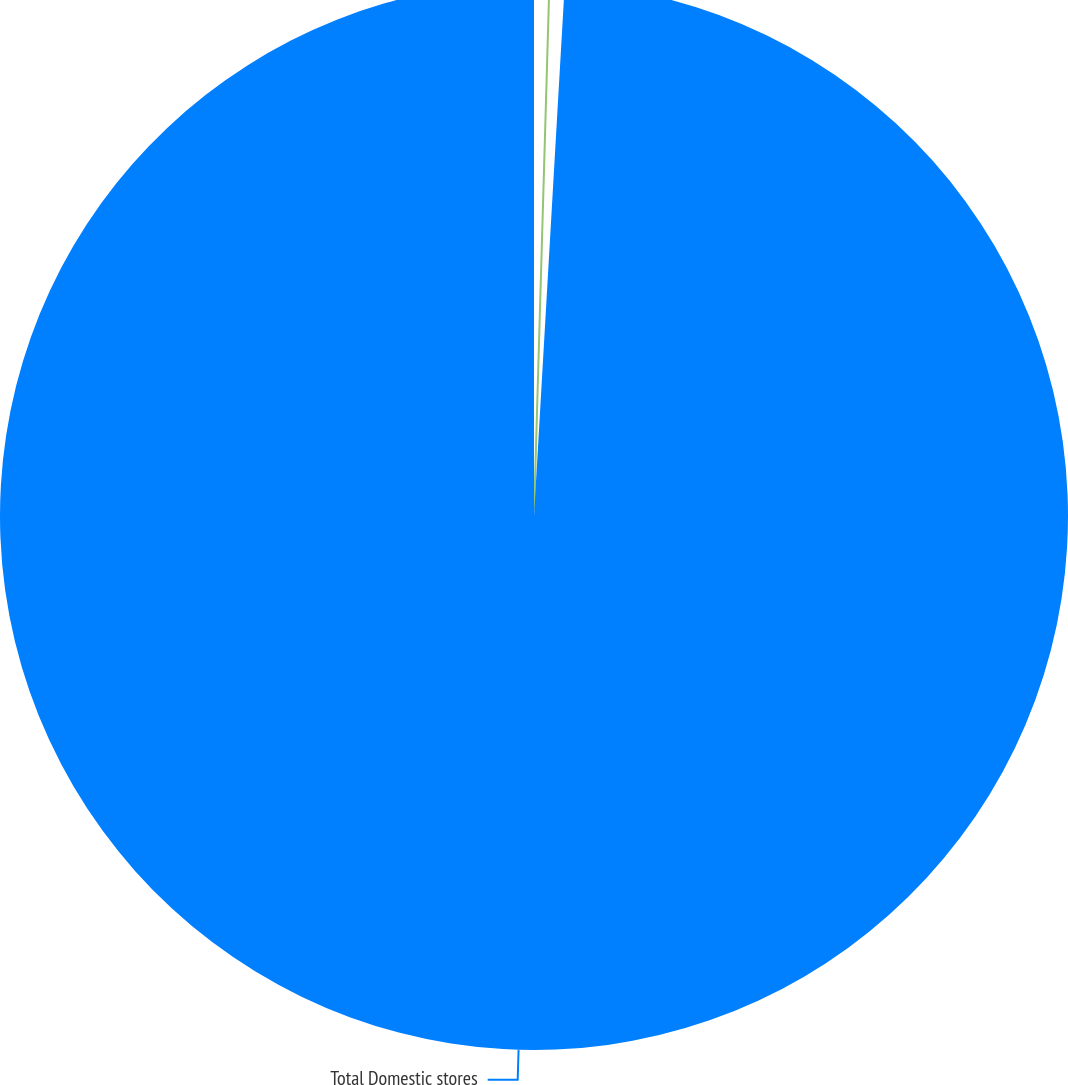Convert chart. <chart><loc_0><loc_0><loc_500><loc_500><pie_chart><fcel>Best Buy Mobile<fcel>Total Domestic stores<nl><fcel>0.92%<fcel>99.08%<nl></chart> 